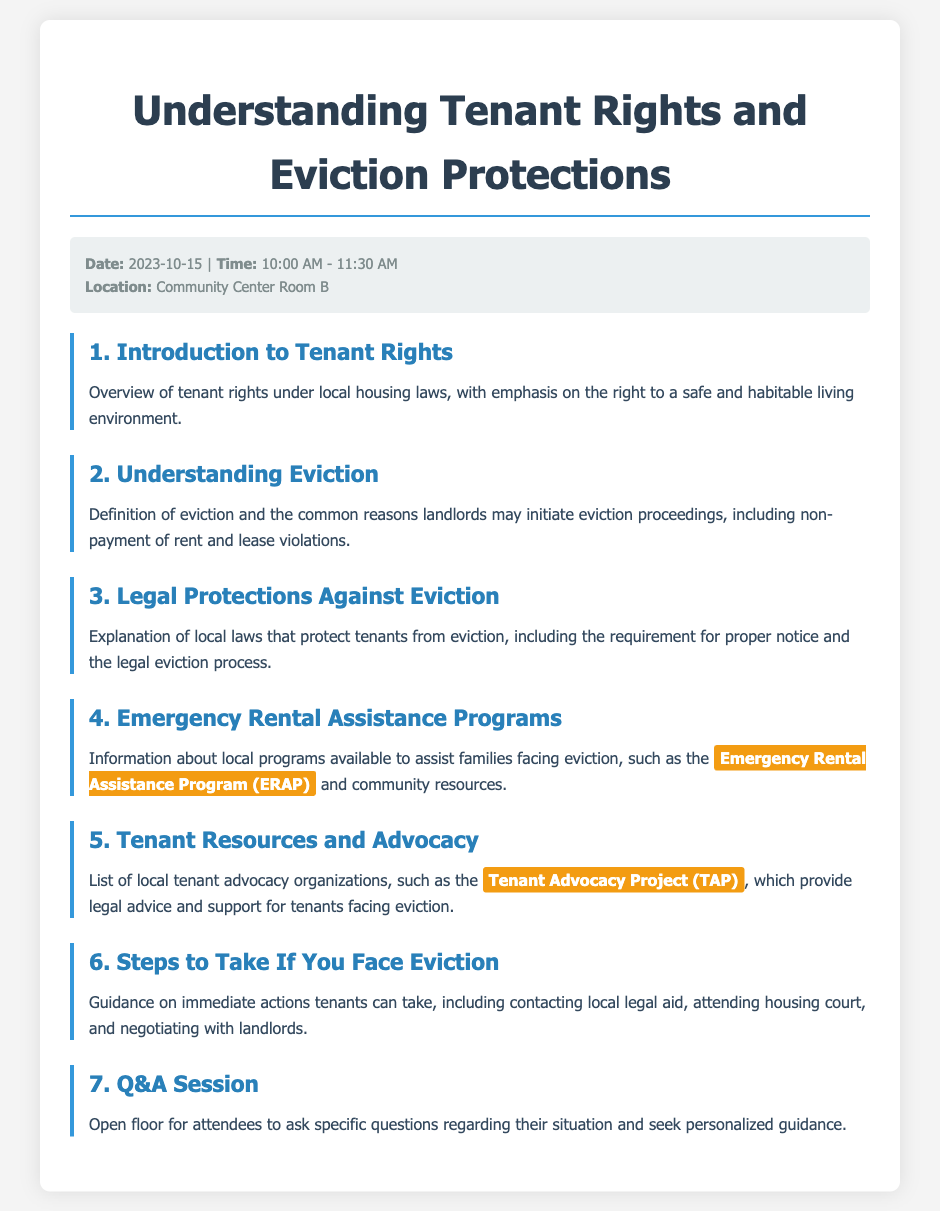What is the date of the meeting? The date of the meeting is specified in the meta-info section of the document as 2023-10-15.
Answer: 2023-10-15 What is the name of the community resource mentioned for rental assistance? The document highlights the Emergency Rental Assistance Program (ERAP) as a resource for families facing eviction.
Answer: Emergency Rental Assistance Program (ERAP) What are the initial topics covered in the agenda? The initial topics include "Introduction to Tenant Rights" and "Understanding Eviction," as listed in the agenda items.
Answer: Introduction to Tenant Rights, Understanding Eviction How long is the meeting scheduled to last? The time duration of the meeting is described in the meta-info as 1 hour and 30 minutes.
Answer: 1 hour and 30 minutes Which organization provides legal advice as per the document? The document lists the Tenant Advocacy Project (TAP) as an organization providing legal advice for tenants.
Answer: Tenant Advocacy Project (TAP) What is the main purpose of the Q&A session? The purpose is to allow attendees to ask specific questions regarding their situation and seek personalized guidance.
Answer: To ask specific questions and seek personalized guidance What is emphasized as a tenant's right in the agenda? The right to a safe and habitable living environment is emphasized under the Introduction to Tenant Rights.
Answer: Safe and habitable living environment What should tenants do if they face eviction, according to the agenda? Tenants are advised to take immediate actions, including contacting local legal aid.
Answer: Contact local legal aid 